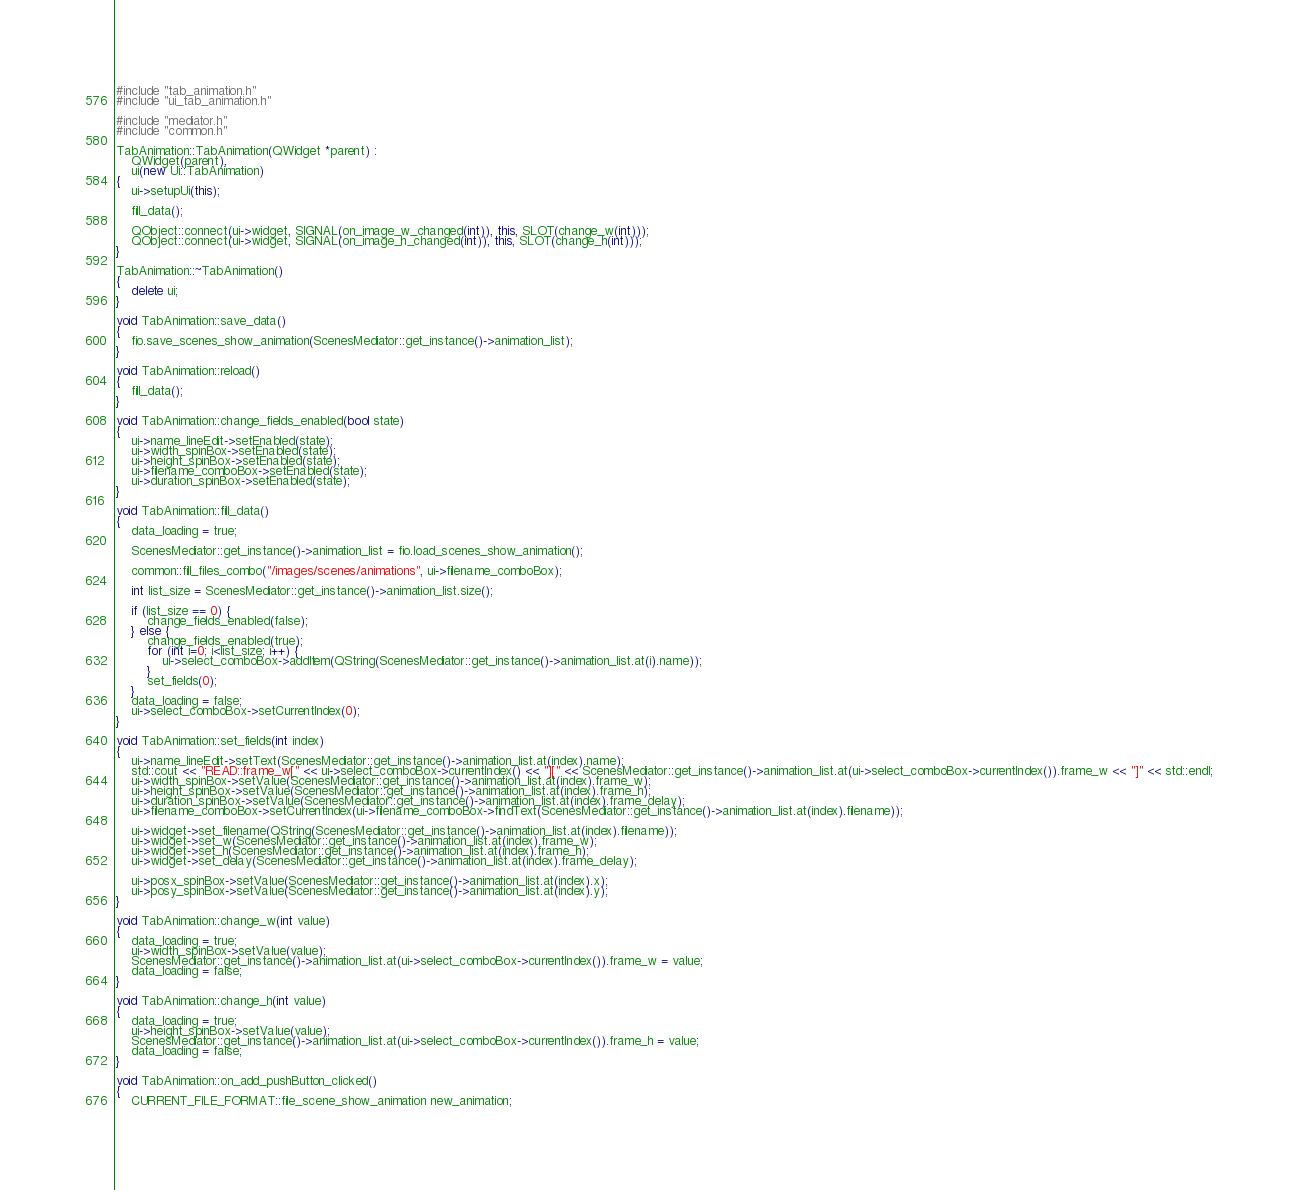<code> <loc_0><loc_0><loc_500><loc_500><_C++_>#include "tab_animation.h"
#include "ui_tab_animation.h"

#include "mediator.h"
#include "common.h"

TabAnimation::TabAnimation(QWidget *parent) :
    QWidget(parent),
    ui(new Ui::TabAnimation)
{
    ui->setupUi(this);

    fill_data();

    QObject::connect(ui->widget, SIGNAL(on_image_w_changed(int)), this, SLOT(change_w(int)));
    QObject::connect(ui->widget, SIGNAL(on_image_h_changed(int)), this, SLOT(change_h(int)));
}

TabAnimation::~TabAnimation()
{
    delete ui;
}

void TabAnimation::save_data()
{
    fio.save_scenes_show_animation(ScenesMediator::get_instance()->animation_list);
}

void TabAnimation::reload()
{
    fill_data();
}

void TabAnimation::change_fields_enabled(bool state)
{
    ui->name_lineEdit->setEnabled(state);
    ui->width_spinBox->setEnabled(state);
    ui->height_spinBox->setEnabled(state);
    ui->filename_comboBox->setEnabled(state);
    ui->duration_spinBox->setEnabled(state);
}

void TabAnimation::fill_data()
{
    data_loading = true;

    ScenesMediator::get_instance()->animation_list = fio.load_scenes_show_animation();

    common::fill_files_combo("/images/scenes/animations", ui->filename_comboBox);

    int list_size = ScenesMediator::get_instance()->animation_list.size();

    if (list_size == 0) {
        change_fields_enabled(false);
    } else {
        change_fields_enabled(true);
        for (int i=0; i<list_size; i++) {
            ui->select_comboBox->addItem(QString(ScenesMediator::get_instance()->animation_list.at(i).name));
        }
        set_fields(0);
    }
    data_loading = false;
    ui->select_comboBox->setCurrentIndex(0);
}

void TabAnimation::set_fields(int index)
{
    ui->name_lineEdit->setText(ScenesMediator::get_instance()->animation_list.at(index).name);
    std::cout << "READ::frame_w[" << ui->select_comboBox->currentIndex() << "][" << ScenesMediator::get_instance()->animation_list.at(ui->select_comboBox->currentIndex()).frame_w << "]" << std::endl;
    ui->width_spinBox->setValue(ScenesMediator::get_instance()->animation_list.at(index).frame_w);
    ui->height_spinBox->setValue(ScenesMediator::get_instance()->animation_list.at(index).frame_h);
    ui->duration_spinBox->setValue(ScenesMediator::get_instance()->animation_list.at(index).frame_delay);
    ui->filename_comboBox->setCurrentIndex(ui->filename_comboBox->findText(ScenesMediator::get_instance()->animation_list.at(index).filename));

    ui->widget->set_filename(QString(ScenesMediator::get_instance()->animation_list.at(index).filename));
    ui->widget->set_w(ScenesMediator::get_instance()->animation_list.at(index).frame_w);
    ui->widget->set_h(ScenesMediator::get_instance()->animation_list.at(index).frame_h);
    ui->widget->set_delay(ScenesMediator::get_instance()->animation_list.at(index).frame_delay);

    ui->posx_spinBox->setValue(ScenesMediator::get_instance()->animation_list.at(index).x);
    ui->posy_spinBox->setValue(ScenesMediator::get_instance()->animation_list.at(index).y);
}

void TabAnimation::change_w(int value)
{
    data_loading = true;
    ui->width_spinBox->setValue(value);
    ScenesMediator::get_instance()->animation_list.at(ui->select_comboBox->currentIndex()).frame_w = value;
    data_loading = false;
}

void TabAnimation::change_h(int value)
{
    data_loading = true;
    ui->height_spinBox->setValue(value);
    ScenesMediator::get_instance()->animation_list.at(ui->select_comboBox->currentIndex()).frame_h = value;
    data_loading = false;
}

void TabAnimation::on_add_pushButton_clicked()
{
    CURRENT_FILE_FORMAT::file_scene_show_animation new_animation;</code> 